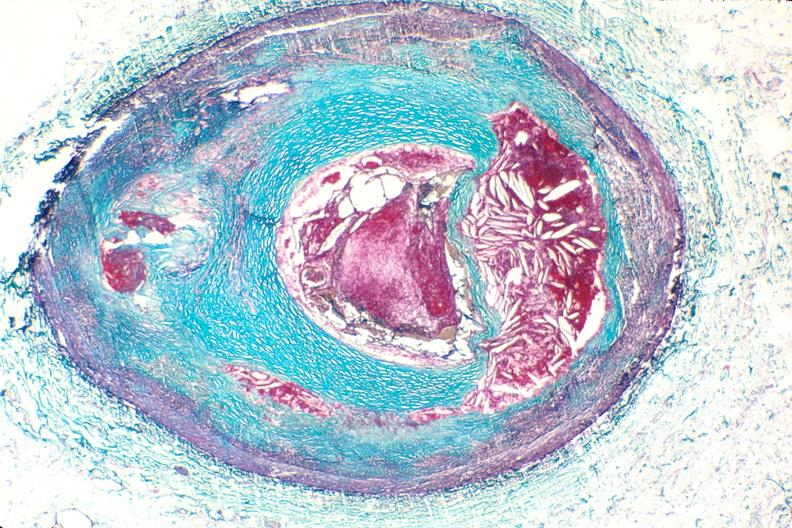s cardiovascular present?
Answer the question using a single word or phrase. Yes 